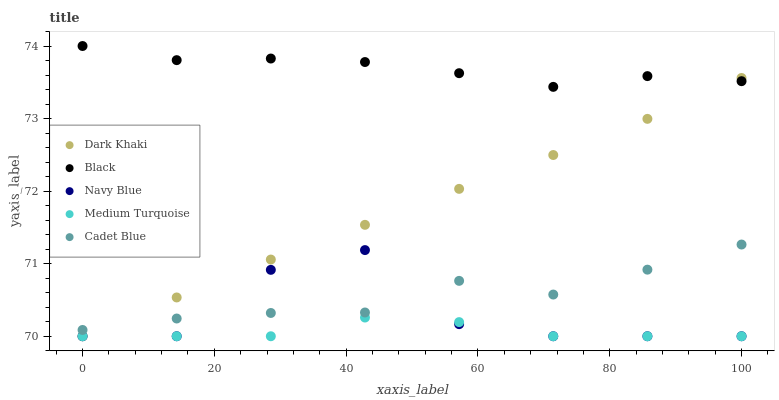Does Medium Turquoise have the minimum area under the curve?
Answer yes or no. Yes. Does Black have the maximum area under the curve?
Answer yes or no. Yes. Does Navy Blue have the minimum area under the curve?
Answer yes or no. No. Does Navy Blue have the maximum area under the curve?
Answer yes or no. No. Is Dark Khaki the smoothest?
Answer yes or no. Yes. Is Navy Blue the roughest?
Answer yes or no. Yes. Is Cadet Blue the smoothest?
Answer yes or no. No. Is Cadet Blue the roughest?
Answer yes or no. No. Does Dark Khaki have the lowest value?
Answer yes or no. Yes. Does Cadet Blue have the lowest value?
Answer yes or no. No. Does Black have the highest value?
Answer yes or no. Yes. Does Navy Blue have the highest value?
Answer yes or no. No. Is Cadet Blue less than Black?
Answer yes or no. Yes. Is Black greater than Cadet Blue?
Answer yes or no. Yes. Does Dark Khaki intersect Black?
Answer yes or no. Yes. Is Dark Khaki less than Black?
Answer yes or no. No. Is Dark Khaki greater than Black?
Answer yes or no. No. Does Cadet Blue intersect Black?
Answer yes or no. No. 